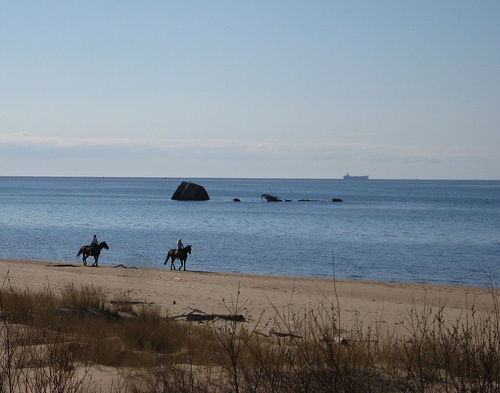Describe the objects in this image and their specific colors. I can see horse in lightblue, black, gray, and blue tones, horse in lightblue, black, gray, and darkblue tones, boat in lightblue, gray, and darkgray tones, people in lightblue, black, navy, gray, and blue tones, and people in lightblue, black, and gray tones in this image. 